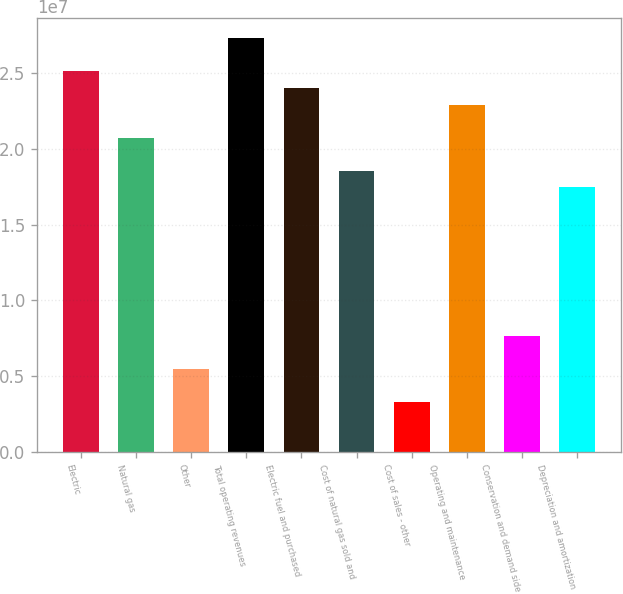Convert chart to OTSL. <chart><loc_0><loc_0><loc_500><loc_500><bar_chart><fcel>Electric<fcel>Natural gas<fcel>Other<fcel>Total operating revenues<fcel>Electric fuel and purchased<fcel>Cost of natural gas sold and<fcel>Cost of sales - other<fcel>Operating and maintenance<fcel>Conservation and demand side<fcel>Depreciation and amortization<nl><fcel>2.51043e+07<fcel>2.07384e+07<fcel>5.45746e+06<fcel>2.72873e+07<fcel>2.40128e+07<fcel>1.85554e+07<fcel>3.27448e+06<fcel>2.29213e+07<fcel>7.64045e+06<fcel>1.74639e+07<nl></chart> 